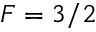<formula> <loc_0><loc_0><loc_500><loc_500>F = 3 / 2</formula> 